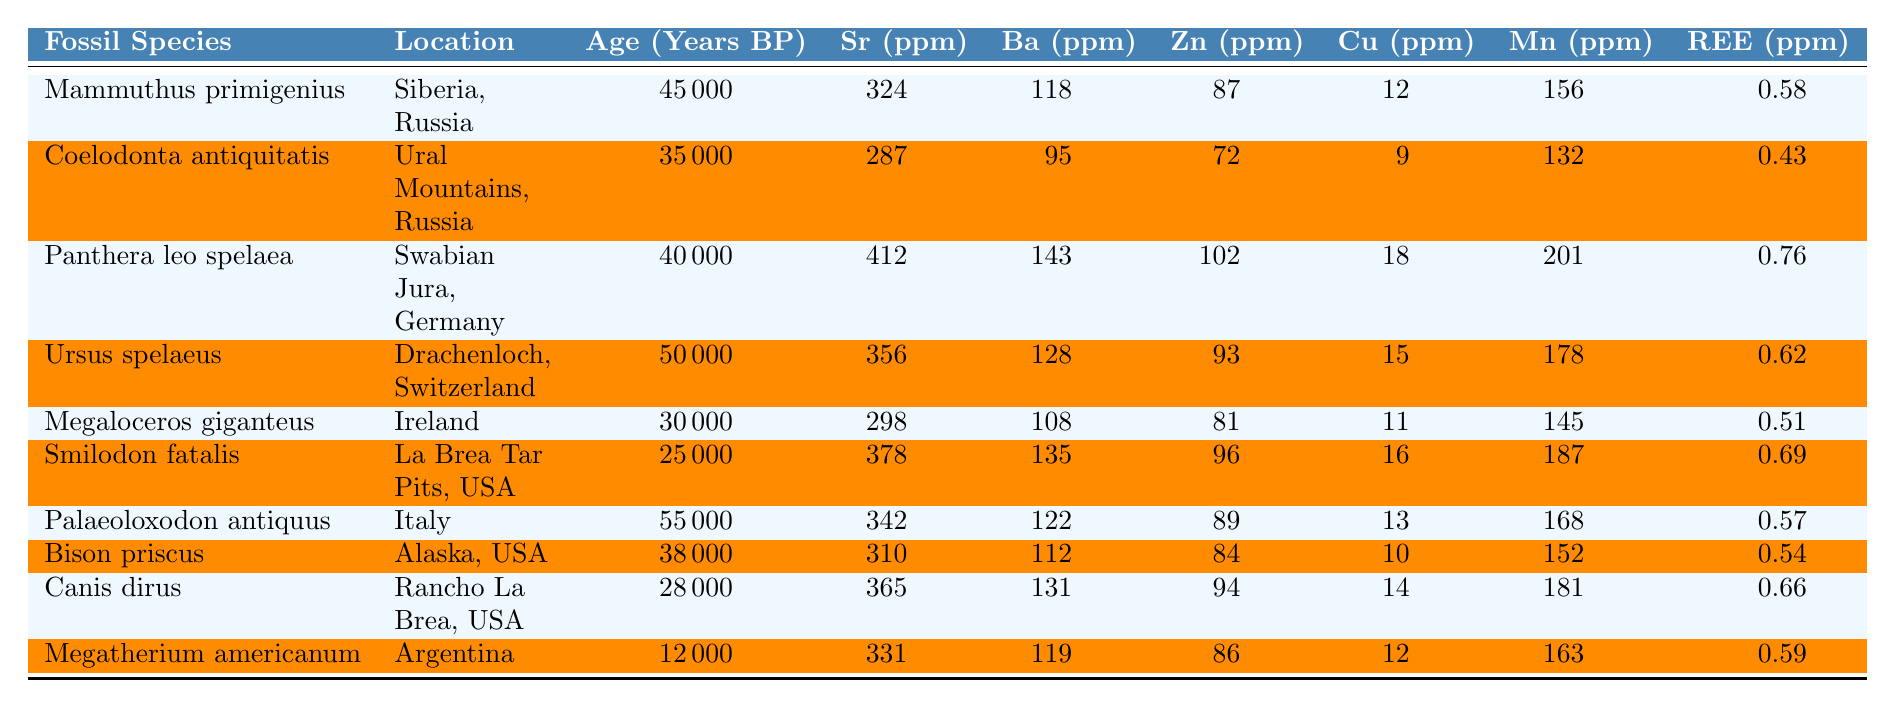What is the age of the oldest fossil in the table? The oldest fossil is from Ursus spelaeus, which is dated at 50000 years BP.
Answer: 50000 years BP Which fossil species has the highest Strontium concentration? Panthera leo spelaea has the highest Strontium concentration at 412 ppm.
Answer: 412 ppm What is the total concentration of Barium in Mammuthus primigenius and Canis dirus? The Barium concentration for Mammuthus primigenius is 118 ppm and for Canis dirus is 131 ppm. Adding these gives 118 + 131 = 249 ppm.
Answer: 249 ppm Is it true that the concentration of Rare Earth Elements in Palaeoloxodon antiquus is greater than in Coelodonta antiquitatis? Palaeoloxodon antiquus has 0.57 ppm, while Coelodonta antiquitatis has 0.43 ppm. Since 0.57 > 0.43, the statement is true.
Answer: Yes Which fossil species has the most Zinc concentration and what is its value? Panthera leo spelaea has the highest Zinc concentration at 102 ppm.
Answer: 102 ppm Calculate the average concentration of Copper across all the fossils in the table. The Copper concentrations are: 12, 9, 18, 15, 11, 16, 13, 10, 14, 12. The sum is 12 + 9 + 18 + 15 + 11 + 16 + 13 + 10 + 14 + 12 = 140. There are 10 fossils, so the average is 140 / 10 = 14.
Answer: 14 What is the location of the Pleistocene fossil with the highest concentration of Manganese? Panthera leo spelaea, located in Swabian Jura, Germany, has the highest Manganese concentration at 201 ppm.
Answer: Swabian Jura, Germany Which two fossils have close values of Strontium concentration, and what are those values? The fossils Ursus spelaeus (356 ppm) and Palaeoloxodon antiquus (342 ppm) have close Strontium values.
Answer: 356 ppm and 342 ppm Determine the total concentration of Rare Earth Elements for fossils older than 40000 years BP. The fossils older than 40000 years are Mammuthus primigenius (0.58 ppm), Ursus spelaeus (0.62 ppm), and Palaeoloxodon antiquus (0.57 ppm). Summing these gives 0.58 + 0.62 + 0.57 = 1.77 ppm.
Answer: 1.77 ppm Which fossil species has the lowest concentration of Barium and what is that concentration? Megaloceros giganteus has the lowest Barium concentration at 108 ppm.
Answer: 108 ppm 